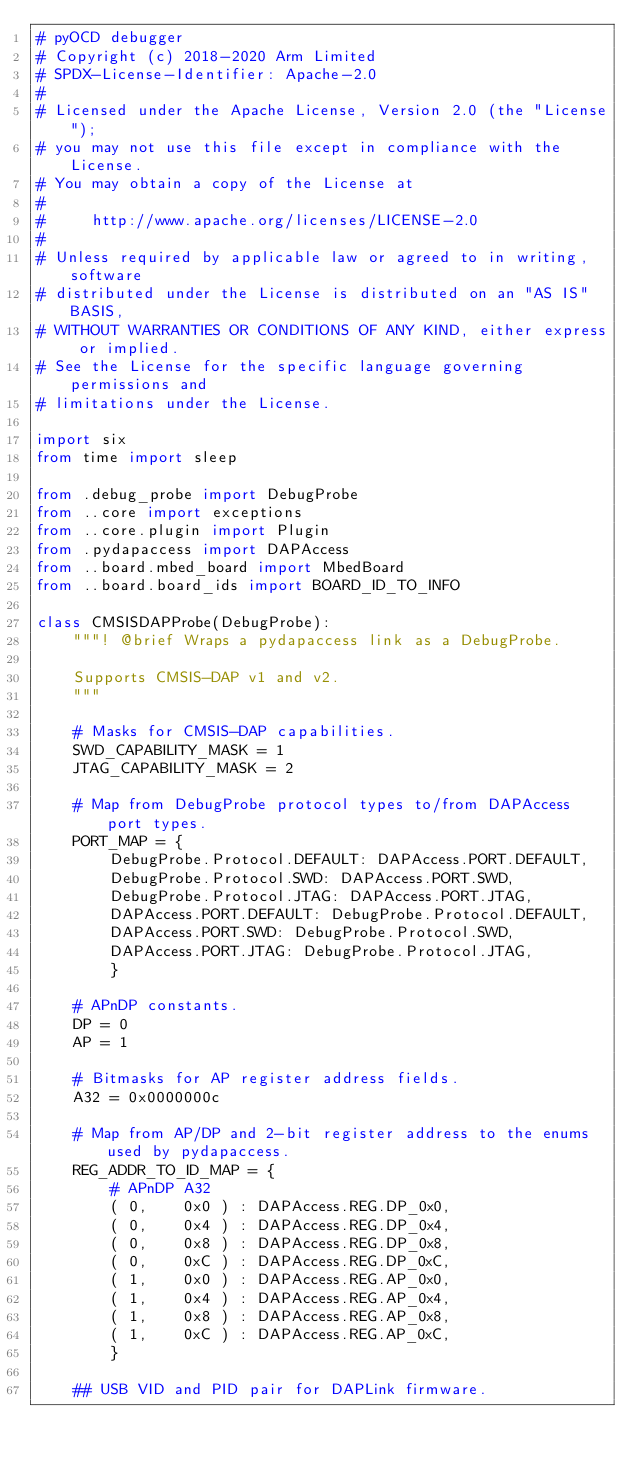Convert code to text. <code><loc_0><loc_0><loc_500><loc_500><_Python_># pyOCD debugger
# Copyright (c) 2018-2020 Arm Limited
# SPDX-License-Identifier: Apache-2.0
#
# Licensed under the Apache License, Version 2.0 (the "License");
# you may not use this file except in compliance with the License.
# You may obtain a copy of the License at
#
#     http://www.apache.org/licenses/LICENSE-2.0
#
# Unless required by applicable law or agreed to in writing, software
# distributed under the License is distributed on an "AS IS" BASIS,
# WITHOUT WARRANTIES OR CONDITIONS OF ANY KIND, either express or implied.
# See the License for the specific language governing permissions and
# limitations under the License.

import six
from time import sleep

from .debug_probe import DebugProbe
from ..core import exceptions
from ..core.plugin import Plugin
from .pydapaccess import DAPAccess
from ..board.mbed_board import MbedBoard
from ..board.board_ids import BOARD_ID_TO_INFO

class CMSISDAPProbe(DebugProbe):
    """! @brief Wraps a pydapaccess link as a DebugProbe.
    
    Supports CMSIS-DAP v1 and v2.
    """

    # Masks for CMSIS-DAP capabilities.
    SWD_CAPABILITY_MASK = 1
    JTAG_CAPABILITY_MASK = 2

    # Map from DebugProbe protocol types to/from DAPAccess port types.
    PORT_MAP = {
        DebugProbe.Protocol.DEFAULT: DAPAccess.PORT.DEFAULT,
        DebugProbe.Protocol.SWD: DAPAccess.PORT.SWD,
        DebugProbe.Protocol.JTAG: DAPAccess.PORT.JTAG,
        DAPAccess.PORT.DEFAULT: DebugProbe.Protocol.DEFAULT,
        DAPAccess.PORT.SWD: DebugProbe.Protocol.SWD,
        DAPAccess.PORT.JTAG: DebugProbe.Protocol.JTAG,
        }
    
    # APnDP constants.
    DP = 0
    AP = 1
    
    # Bitmasks for AP register address fields.
    A32 = 0x0000000c
    
    # Map from AP/DP and 2-bit register address to the enums used by pydapaccess.
    REG_ADDR_TO_ID_MAP = {
        # APnDP A32
        ( 0,    0x0 ) : DAPAccess.REG.DP_0x0,
        ( 0,    0x4 ) : DAPAccess.REG.DP_0x4,
        ( 0,    0x8 ) : DAPAccess.REG.DP_0x8,
        ( 0,    0xC ) : DAPAccess.REG.DP_0xC,
        ( 1,    0x0 ) : DAPAccess.REG.AP_0x0,
        ( 1,    0x4 ) : DAPAccess.REG.AP_0x4,
        ( 1,    0x8 ) : DAPAccess.REG.AP_0x8,
        ( 1,    0xC ) : DAPAccess.REG.AP_0xC,
        }
    
    ## USB VID and PID pair for DAPLink firmware.</code> 